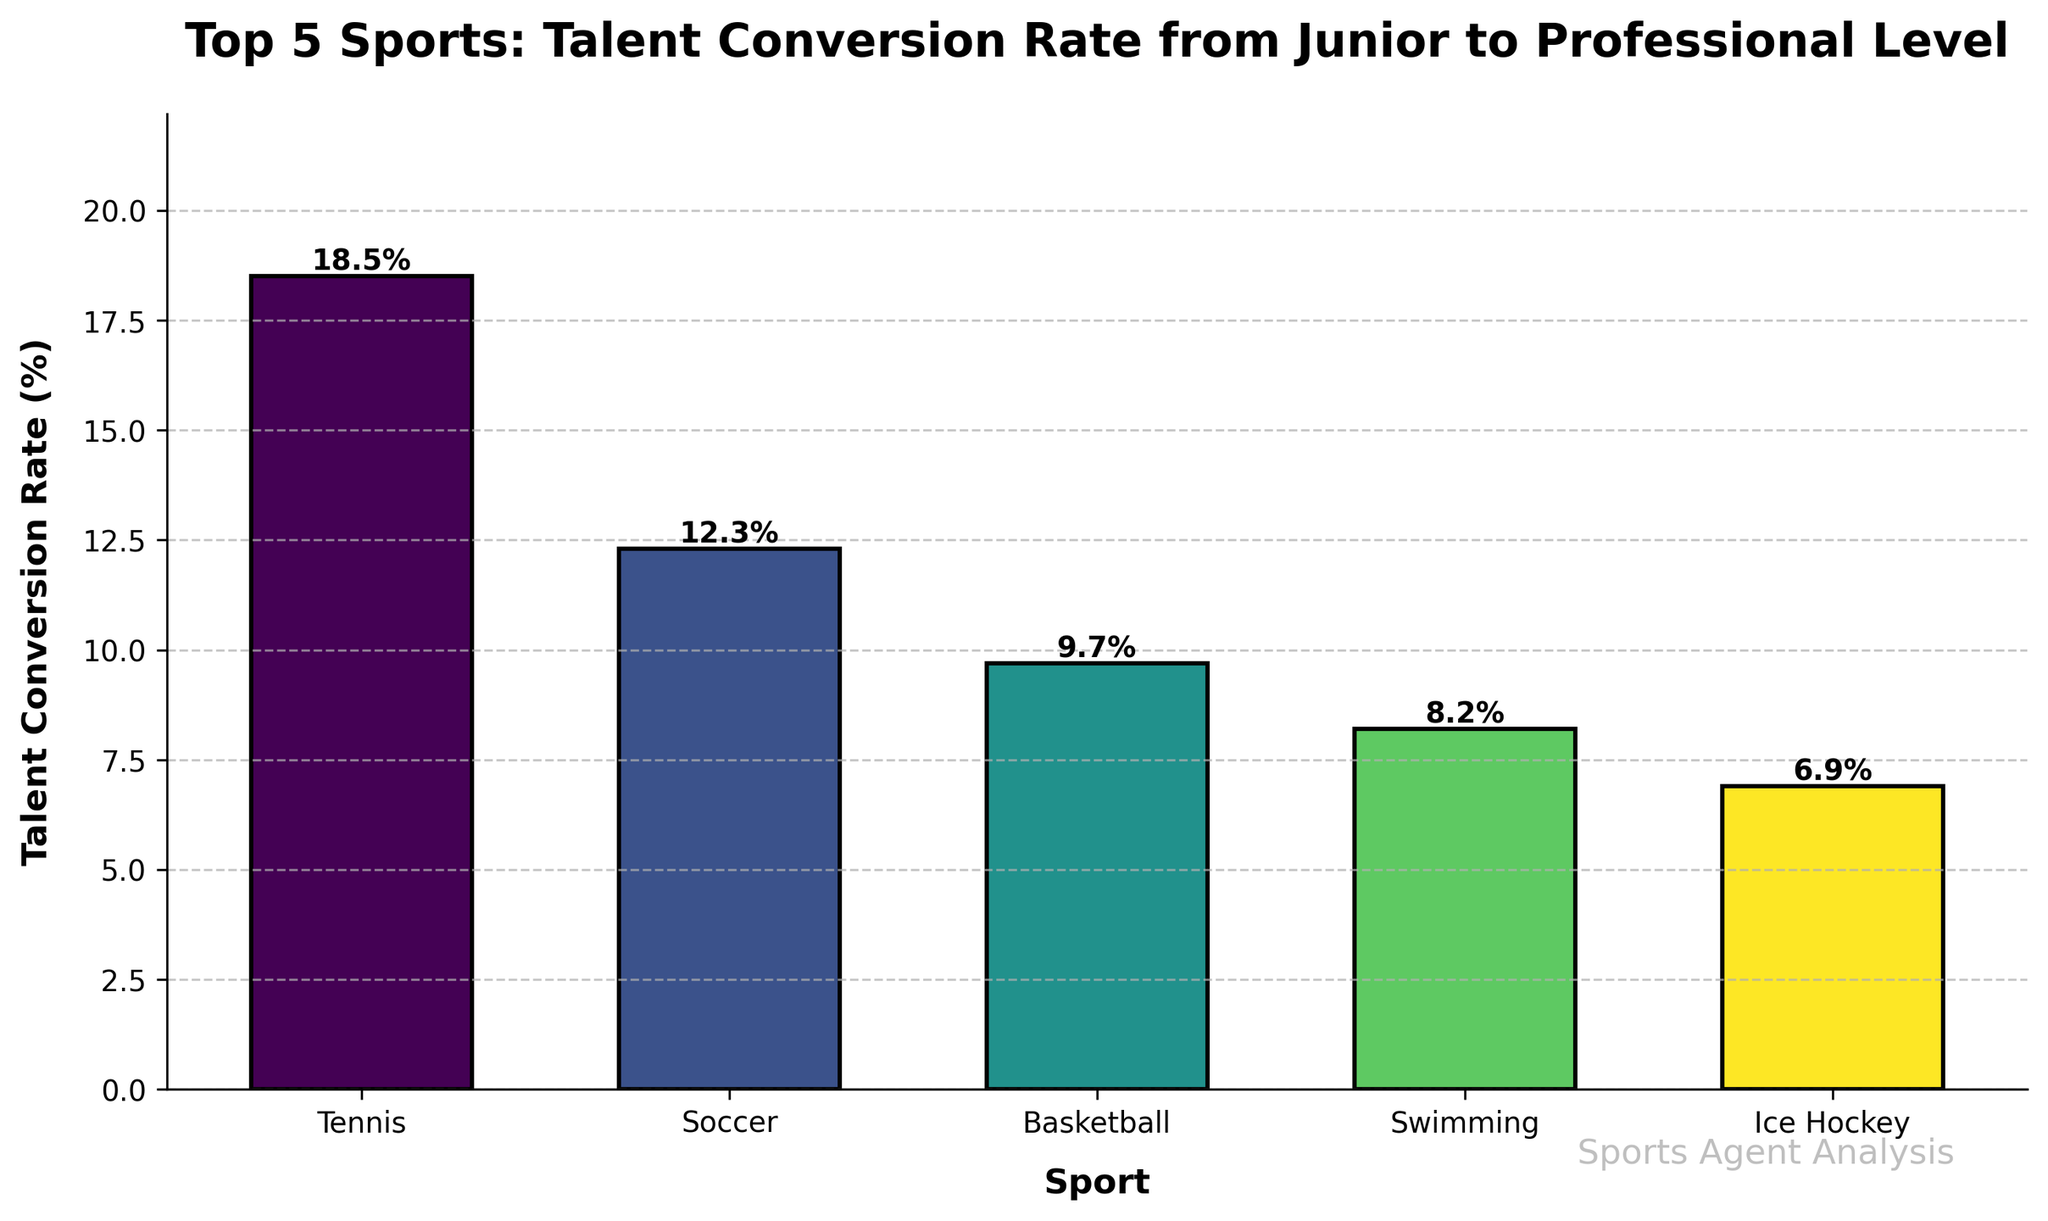Which sport has the highest talent conversion rate? The bar chart shows the talent conversion rates for different sports. The highest bar represents Tennis with a conversion rate of 18.5%.
Answer: Tennis Which two sports have the smallest difference in talent conversion rates? Compare the percentages on the x-axis for each sport. Swimming (8.2%) and Ice Hockey (6.9%) have the smallest difference. The difference is 8.2 - 6.9 = 1.3%.
Answer: Swimming and Ice Hockey What is the difference in talent conversion rates between Tennis and Basketball? Refer to the bars representing Tennis (18.5%) and Basketball (9.7%). The difference is 18.5 - 9.7 = 8.8%.
Answer: 8.8% Which sports have a talent conversion rate lower than 10%? Identify the bars with talent conversion rates lower than 10%. Basketball (9.7%), Swimming (8.2%), and Ice Hockey (6.9%) meet this criterion.
Answer: Basketball, Swimming, Ice Hockey What is the average talent conversion rate of the top 5 sports? Sum the talent conversion rates of all sports and divide by the number of sports: (18.5 + 12.3 + 9.7 + 8.2 + 6.9) / 5 = 55.6 / 5 = 11.12%.
Answer: 11.12% How much taller is the bar for Tennis compared to Soccer? Tennis has a conversion rate of 18.5%, while Soccer has 12.3%. The difference in height is 18.5 - 12.3 = 6.2%.
Answer: 6.2% Which sport has a conversion rate closest to the average conversion rate of all five sports? First, calculate the average of the top 5 sports: (18.5 + 12.3 + 9.7 + 8.2 + 6.9) / 5 = 11.12%. Basketball’s rate of 9.7% is the closest to this average.
Answer: Basketball How much higher is the talent conversion rate of Tennis compared to the lowest sport? Tennis has a rate of 18.5%, and Ice Hockey has the lowest rate at 6.9%. The difference is 18.5 - 6.9 = 11.6%.
Answer: 11.6% Which sports have a talent conversion rate higher than Soccer? Identify sports with a conversion rate higher than Soccer’s 12.3%. Only Tennis meets this criterion with a rate of 18.5%.
Answer: Tennis 